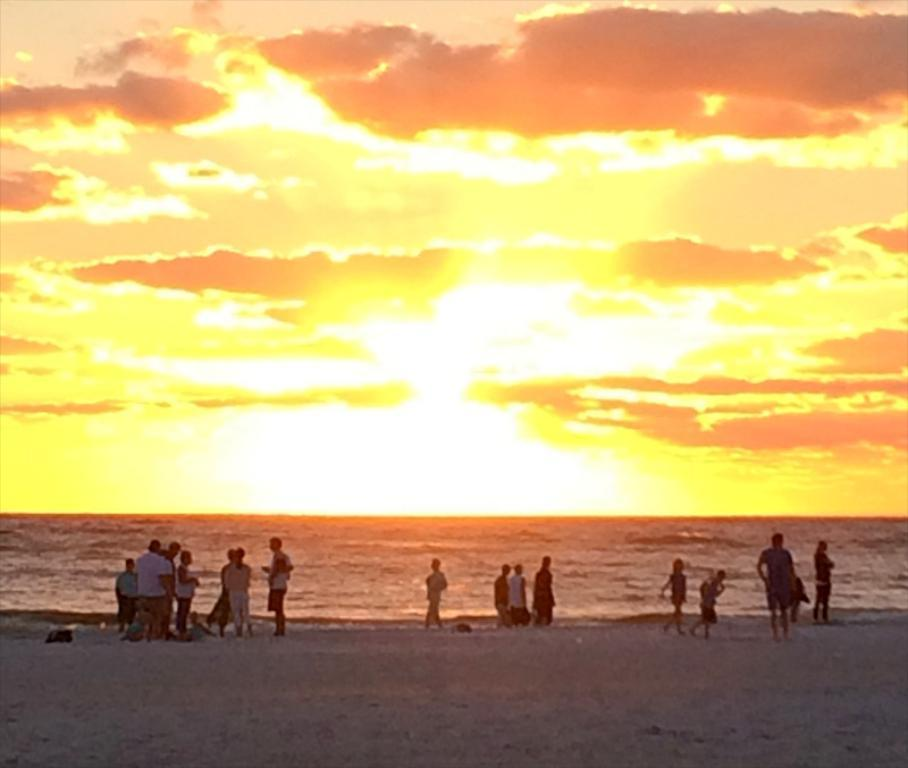What is the location of the people in the image? The people are standing on the sea shore. What celestial body is visible in the image? The sun is visible in the image. What type of toothpaste is being used by the people on the sea shore in the image? There is no toothpaste present in the image, as it features people standing on the sea shore and the sun. Can you provide an example of a bird species that might be flying in the sky in the image? There is no bird species mentioned or depicted in the image, as it only features people standing on the sea shore and the sun. 